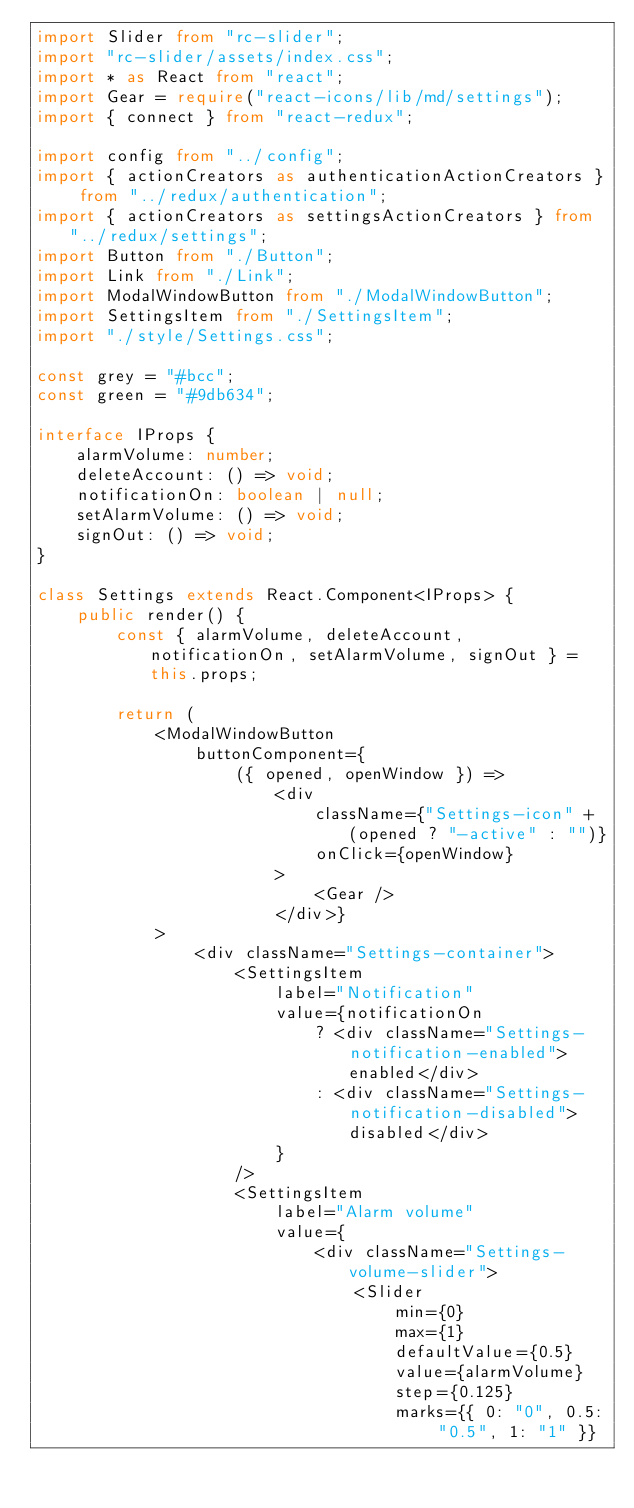Convert code to text. <code><loc_0><loc_0><loc_500><loc_500><_TypeScript_>import Slider from "rc-slider";
import "rc-slider/assets/index.css";
import * as React from "react";
import Gear = require("react-icons/lib/md/settings");
import { connect } from "react-redux";

import config from "../config";
import { actionCreators as authenticationActionCreators } from "../redux/authentication";
import { actionCreators as settingsActionCreators } from "../redux/settings";
import Button from "./Button";
import Link from "./Link";
import ModalWindowButton from "./ModalWindowButton";
import SettingsItem from "./SettingsItem";
import "./style/Settings.css";

const grey = "#bcc";
const green = "#9db634";

interface IProps {
    alarmVolume: number;
    deleteAccount: () => void;
    notificationOn: boolean | null;
    setAlarmVolume: () => void;
    signOut: () => void;
}

class Settings extends React.Component<IProps> {
    public render() {
        const { alarmVolume, deleteAccount, notificationOn, setAlarmVolume, signOut } = this.props;

        return (
            <ModalWindowButton
                buttonComponent={
                    ({ opened, openWindow }) =>
                        <div
                            className={"Settings-icon" + (opened ? "-active" : "")}
                            onClick={openWindow}
                        >
                            <Gear />
                        </div>}
            >
                <div className="Settings-container">
                    <SettingsItem
                        label="Notification"
                        value={notificationOn
                            ? <div className="Settings-notification-enabled">enabled</div>
                            : <div className="Settings-notification-disabled">disabled</div>
                        }
                    />
                    <SettingsItem
                        label="Alarm volume"
                        value={
                            <div className="Settings-volume-slider">
                                <Slider
                                    min={0}
                                    max={1}
                                    defaultValue={0.5}
                                    value={alarmVolume}
                                    step={0.125}
                                    marks={{ 0: "0", 0.5: "0.5", 1: "1" }}</code> 